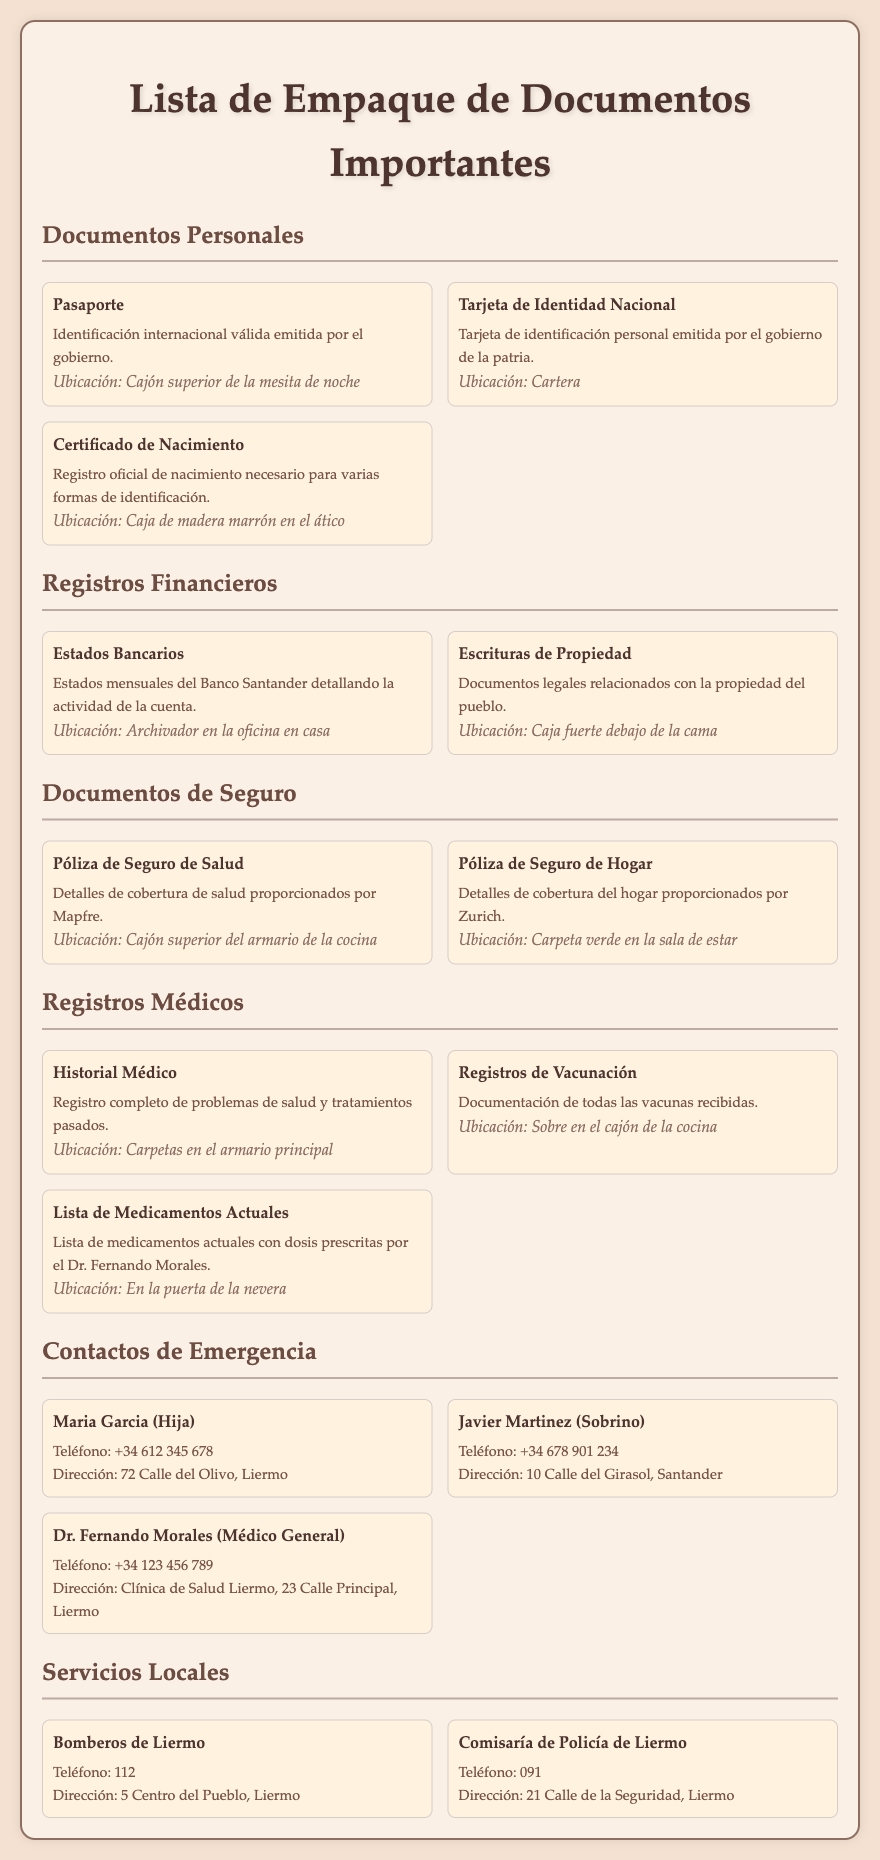¿Qué documento personal se encuentra en la ubicación del cajón superior de la mesita de noche? El pasaporte es el documento personal que se guarda en esa ubicación.
Answer: Pasaporte ¿Cuáles son los detalles de la póliza de seguro de hogar? Los detalles mencionan que la póliza proporciona cobertura del hogar, y es emitida por Zurich.
Answer: Póliza de Seguro de Hogar ¿Dónde se almacenan los registros de vacunación? La ubicación es un sobre en el cajón de la cocina.
Answer: Sobre en el cajón de la cocina ¿Cuántos contactos de emergencia hay en la lista? Hay tres contactos de emergencia mencionados en la lista.
Answer: Tres ¿Quién es el médico de cabecera listado en los contactos de emergencia? El contacto listado como médico de cabecera es el Dr. Fernando Morales.
Answer: Dr. Fernando Morales ¿Qué documento se encuentra en la caja fuerte debajo de la cama? La escritura de propiedad está almacenada en la caja fuerte.
Answer: Escritura de Propiedad ¿Cuál es el número de teléfono de Maria Garcia? El número de teléfono de Maria Garcia es +34 612 345 678.
Answer: +34 612 345 678 ¿Cuál es el lugar donde se guardan los estados bancarios? Los estados bancarios están almacenados en un archivador en la oficina en casa.
Answer: Archivador en la oficina en casa ¿A qué dirección corresponde la comisaría de policía de Liermo? La dirección de la comisaría de policía es 21 Calle de la Seguridad, Liermo.
Answer: 21 Calle de la Seguridad, Liermo 